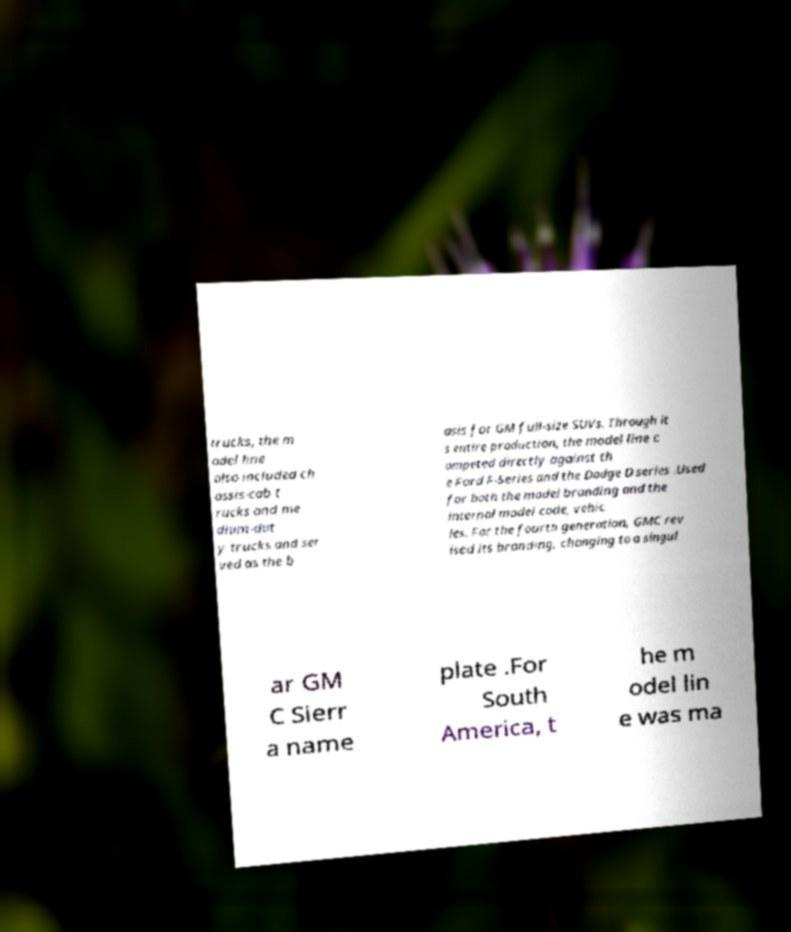For documentation purposes, I need the text within this image transcribed. Could you provide that? trucks, the m odel line also included ch assis-cab t rucks and me dium-dut y trucks and ser ved as the b asis for GM full-size SUVs. Through it s entire production, the model line c ompeted directly against th e Ford F-Series and the Dodge D series .Used for both the model branding and the internal model code, vehic les. For the fourth generation, GMC rev ised its branding, changing to a singul ar GM C Sierr a name plate .For South America, t he m odel lin e was ma 